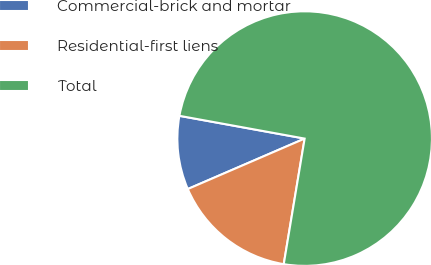Convert chart to OTSL. <chart><loc_0><loc_0><loc_500><loc_500><pie_chart><fcel>Commercial-brick and mortar<fcel>Residential-first liens<fcel>Total<nl><fcel>9.35%<fcel>15.89%<fcel>74.77%<nl></chart> 